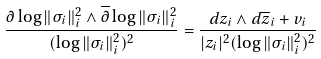<formula> <loc_0><loc_0><loc_500><loc_500>\frac { \partial \log \| \sigma _ { i } \| ^ { 2 } _ { i } \wedge \overline { \partial } \log \| \sigma _ { i } \| ^ { 2 } _ { i } } { ( \log \| \sigma _ { i } \| ^ { 2 } _ { i } ) ^ { 2 } } = \frac { d z _ { i } \wedge d \overline { z } _ { i } + v _ { i } } { | z _ { i } | ^ { 2 } ( \log \| \sigma _ { i } \| ^ { 2 } _ { i } ) ^ { 2 } }</formula> 